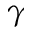<formula> <loc_0><loc_0><loc_500><loc_500>\gamma</formula> 